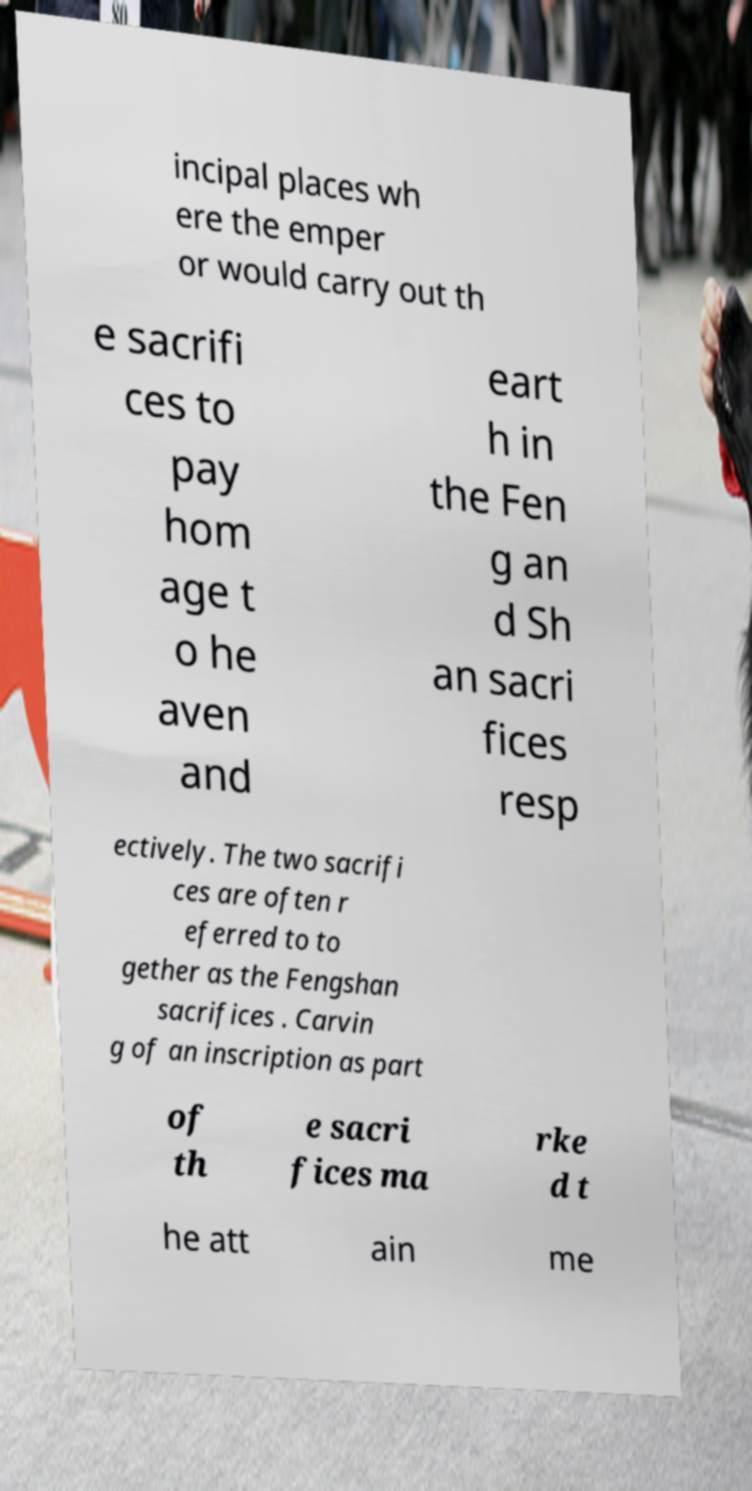What messages or text are displayed in this image? I need them in a readable, typed format. incipal places wh ere the emper or would carry out th e sacrifi ces to pay hom age t o he aven and eart h in the Fen g an d Sh an sacri fices resp ectively. The two sacrifi ces are often r eferred to to gether as the Fengshan sacrifices . Carvin g of an inscription as part of th e sacri fices ma rke d t he att ain me 